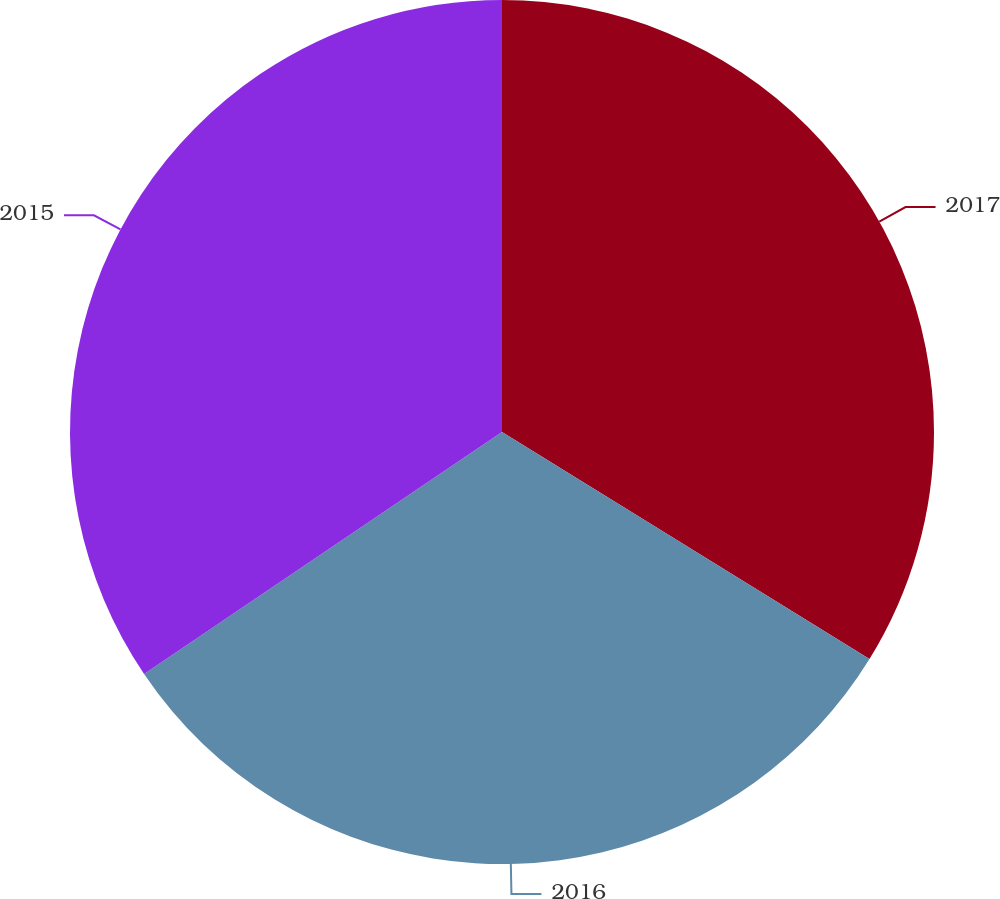Convert chart to OTSL. <chart><loc_0><loc_0><loc_500><loc_500><pie_chart><fcel>2017<fcel>2016<fcel>2015<nl><fcel>33.81%<fcel>31.73%<fcel>34.46%<nl></chart> 